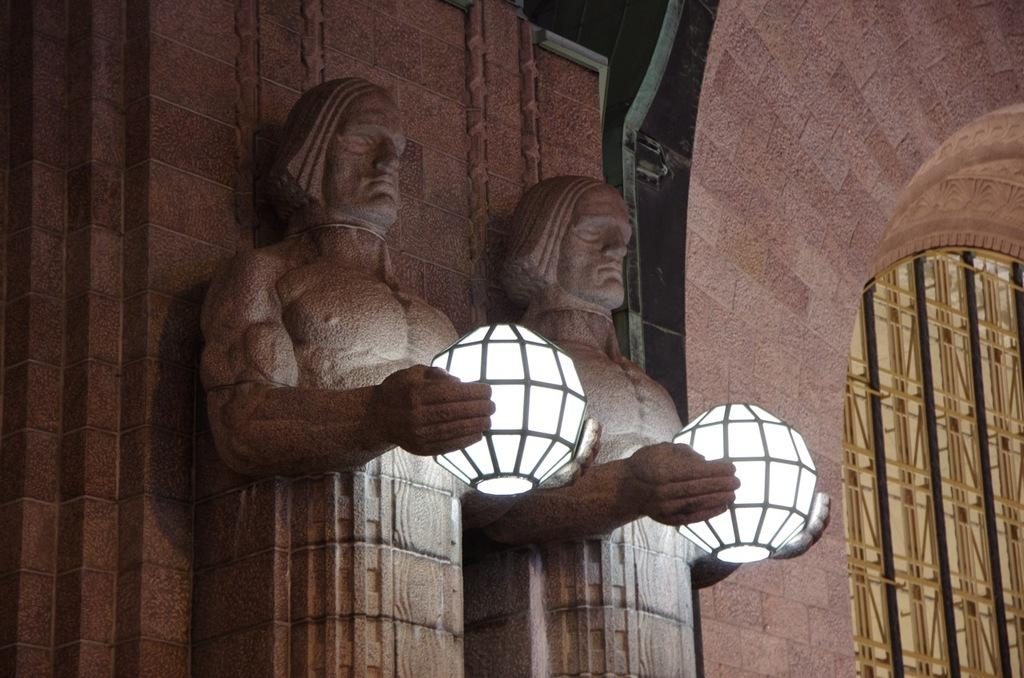What is present on the wall in the image? There are sculptures of a man on the wall. What are the sculptures holding? The sculptures are holding lamps. Where is the window located in relation to the wall? The window is to the right of the wall in the image. What is the temperature of the room in the image? The provided facts do not mention the temperature of the room, so it cannot be determined from the image. 